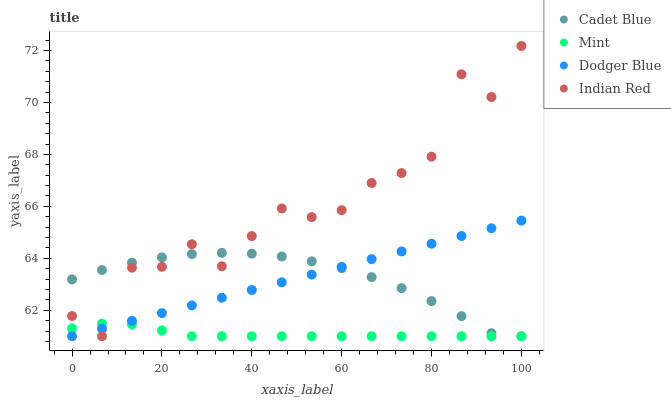Does Mint have the minimum area under the curve?
Answer yes or no. Yes. Does Indian Red have the maximum area under the curve?
Answer yes or no. Yes. Does Cadet Blue have the minimum area under the curve?
Answer yes or no. No. Does Cadet Blue have the maximum area under the curve?
Answer yes or no. No. Is Dodger Blue the smoothest?
Answer yes or no. Yes. Is Indian Red the roughest?
Answer yes or no. Yes. Is Cadet Blue the smoothest?
Answer yes or no. No. Is Cadet Blue the roughest?
Answer yes or no. No. Does Dodger Blue have the lowest value?
Answer yes or no. Yes. Does Indian Red have the highest value?
Answer yes or no. Yes. Does Cadet Blue have the highest value?
Answer yes or no. No. Does Dodger Blue intersect Indian Red?
Answer yes or no. Yes. Is Dodger Blue less than Indian Red?
Answer yes or no. No. Is Dodger Blue greater than Indian Red?
Answer yes or no. No. 